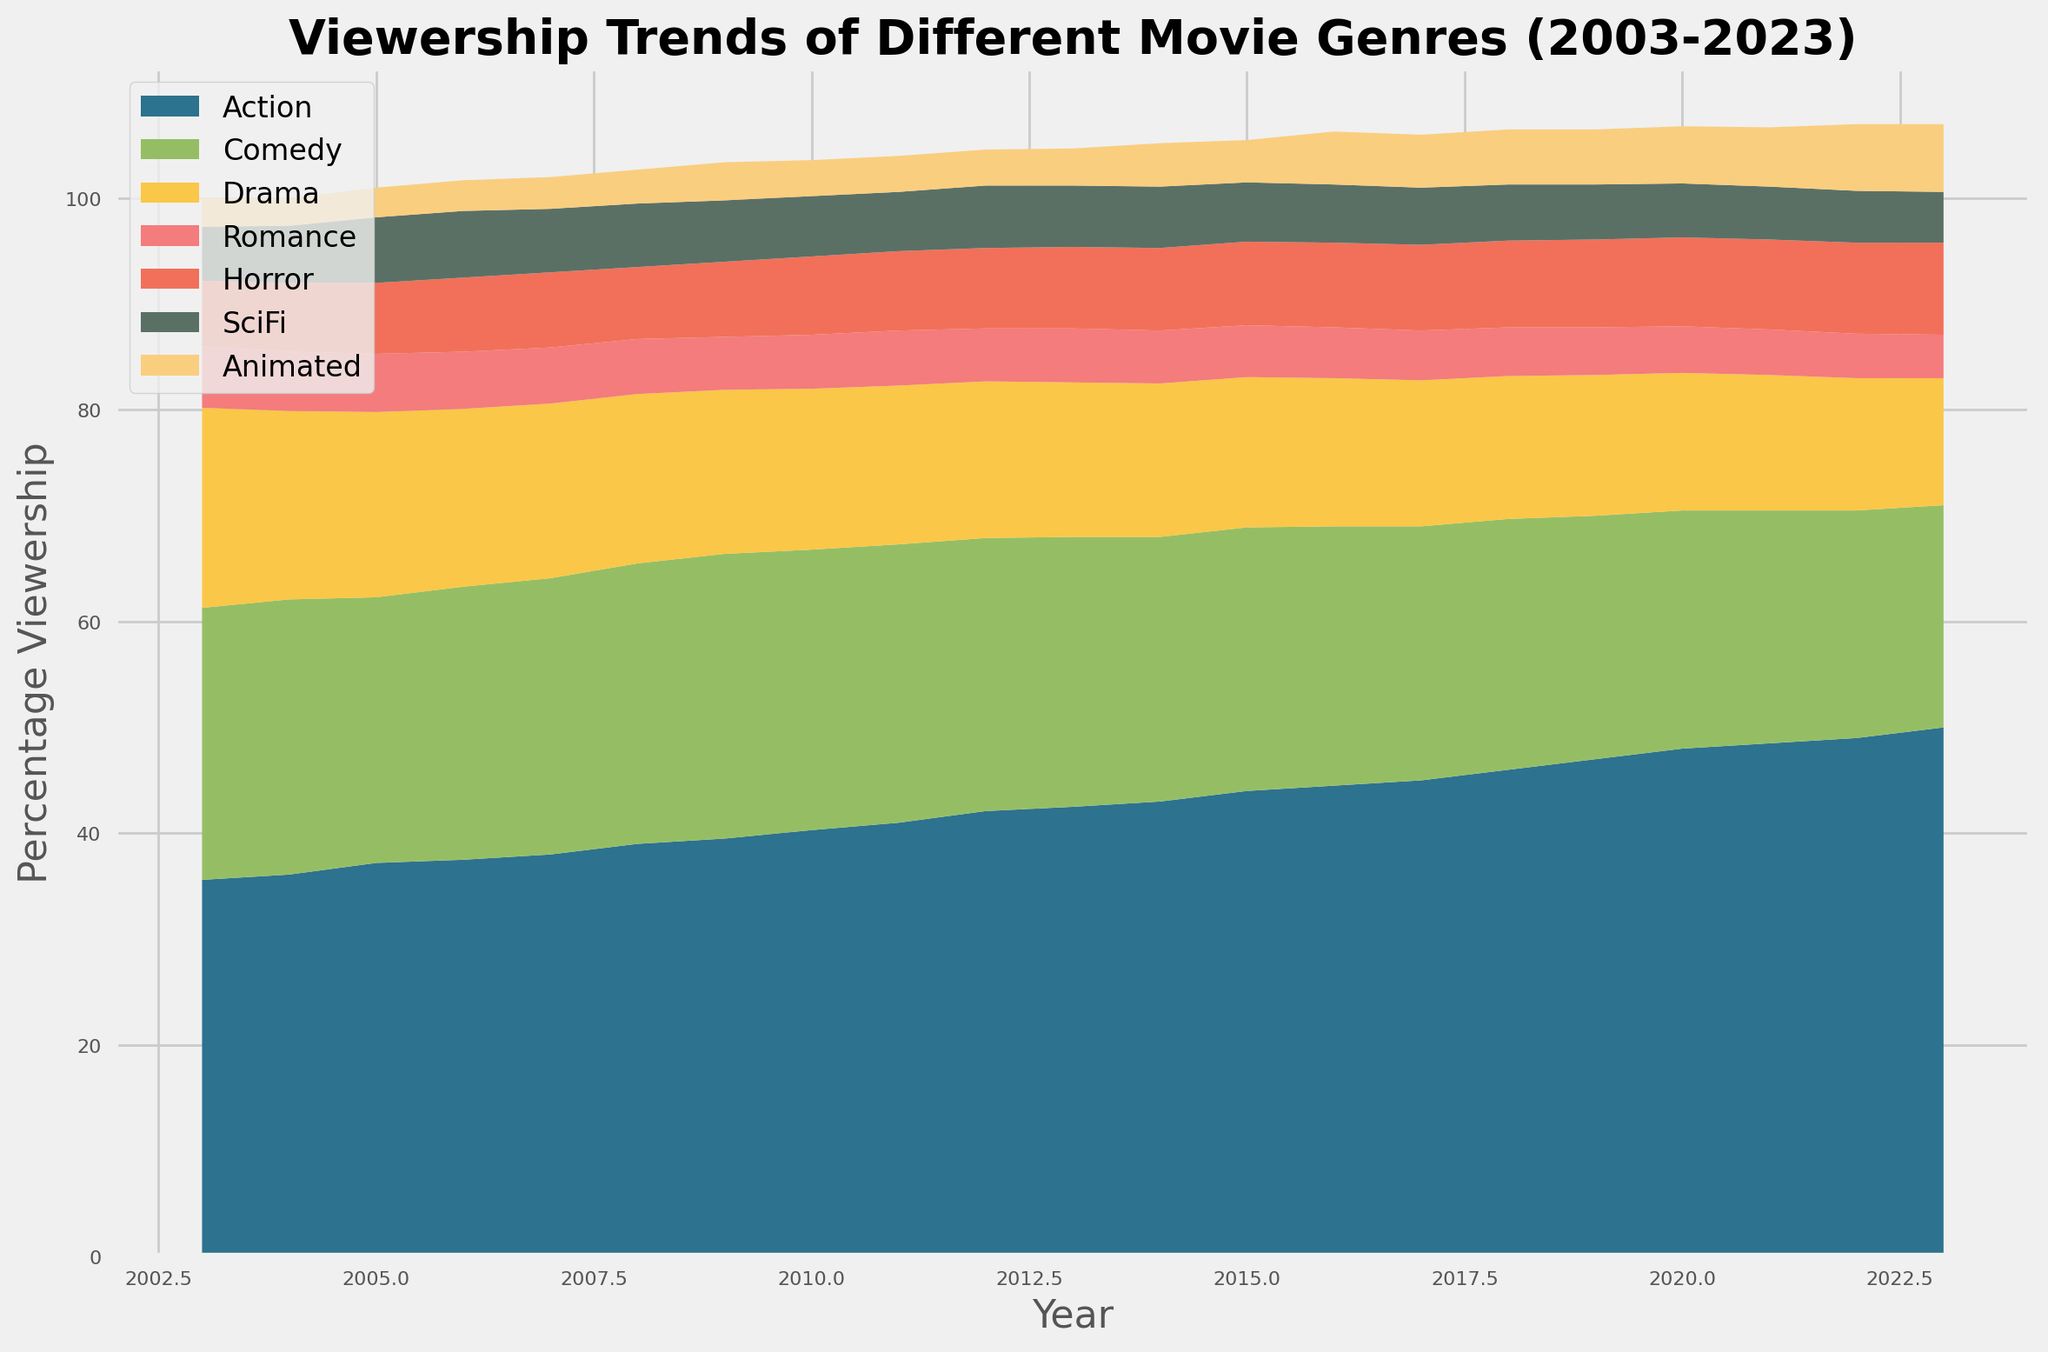Which genre had the highest viewership percentage in 2023? To determine this, look at the heights of the areas in the chart for the year 2023 and identify the genre with the maximum value. In 2023, the Action genre has the highest viewership percentage.
Answer: Action Which genre saw the largest increase in viewership percentage from 2003 to 2023? To answer this, compare the viewership percentages for each genre in 2003 and 2023, then subtract the 2003 value from the 2023 value for each genre. Action increased from 35.6% in 2003 to 50.0% in 2023, the largest gain among all genres.
Answer: Action How did the viewership trend for the SciFi genre change over the past 20 years? Observe the shape and progression of the SciFi area in the chart. SciFi viewership rose from 5.1% in 2003 to 6.4% in 2023, peaking around 2011-2012.
Answer: Increasing What was the combined viewership percentage for Romance and Horror genres in 2010? Add the percentages of Romance and Horror for the year 2010: 5.1% (Romance) + 7.4% (Horror) = 12.5%.
Answer: 12.5% Which year had the lowest viewership percentage for the Comedy genre? Identify the lowest point in the Comedy area by following its outline over time. The Comedy genre reached its lowest viewership percentage in 2023 at 21.0%.
Answer: 2023 Is the viewership percentage for the Animated genre higher or lower in 2023 compared to 2003? Compare the heights at the start and end of the Animated area. In 2023, it is 6.4%, which is higher than 2.7% in 2003.
Answer: Higher Identify two genres that show a decreasing trend in viewership percentage from 2003 to 2023. Observe the general direction of the areas over time. Both Comedy and Drama genres show a decreasing trend, visible by their overall declining heights.
Answer: Comedy, Drama What is the difference in viewership percentage between Action and Drama genres in 2023? Subtract the percentage of the Drama genre in 2023 from that of Action genre. In 2023, Action is 50.0% and Drama is 12.0%; thus, the difference is 50.0% - 12.0% = 38.0%.
Answer: 38.0% 